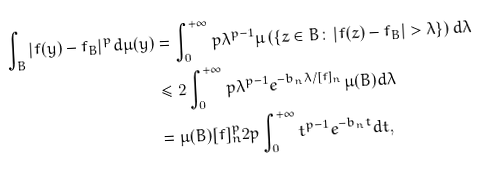<formula> <loc_0><loc_0><loc_500><loc_500>\int _ { B } | f ( y ) - f _ { B } | ^ { p } d \mu ( y ) & = \int _ { 0 } ^ { + \infty } p \lambda ^ { p - 1 } \mu \left ( \left \{ z \in B \colon \left | f ( z ) - f _ { B } \right | > \lambda \right \} \right ) d \lambda \\ & \leq 2 \int _ { 0 } ^ { + \infty } p \lambda ^ { p - 1 } e ^ { - b _ { n } \lambda / [ f ] _ { n } } \mu ( B ) d \lambda \, \\ & = \mu ( B ) [ f ] _ { n } ^ { p } 2 p \int _ { 0 } ^ { + \infty } t ^ { p - 1 } e ^ { - b _ { n } t } d t ,</formula> 